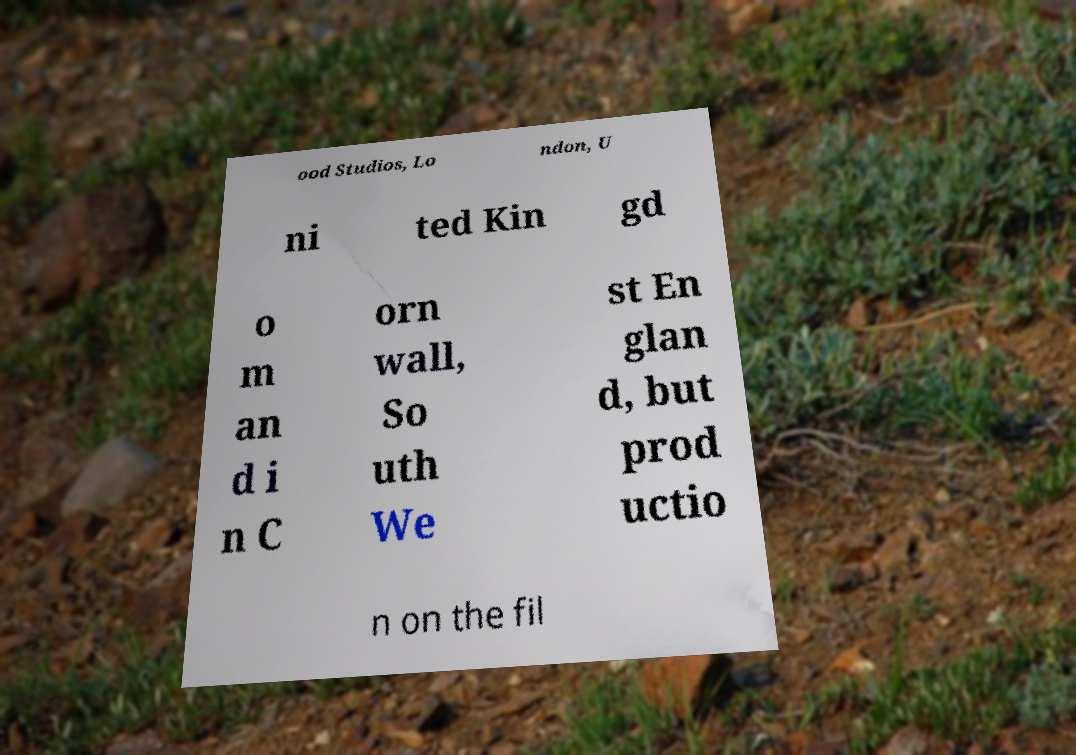I need the written content from this picture converted into text. Can you do that? ood Studios, Lo ndon, U ni ted Kin gd o m an d i n C orn wall, So uth We st En glan d, but prod uctio n on the fil 